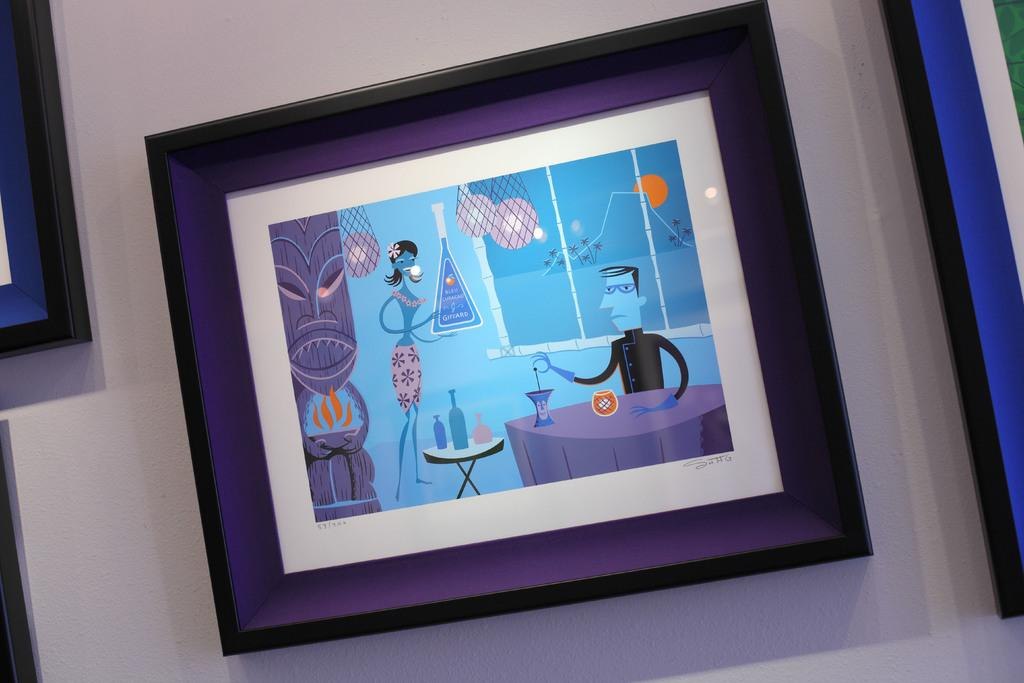What is hanging on the wall in the image? There are photo frames on the wall in the image. What can be seen in one of the photo frames? One of the frames contains cartoon images of people. What type of furniture is present in the image? There are tables in the image. What type of containers can be seen in the image? There are bottles in the image. What decorative items are present in the image? There are balloons in the image. Can you describe any other objects present in the image? There are other objects present in the image, but their specific details are not mentioned in the provided facts. What type of snow can be seen on the sidewalk in the image? There is no snow or sidewalk present in the image; the focus is on the photo frames, tables, bottles, and balloons. Can you describe the snail crawling on the cartoon character in the image? There is no snail present in the image; the cartoon images in the photo frame do not depict any snails. 